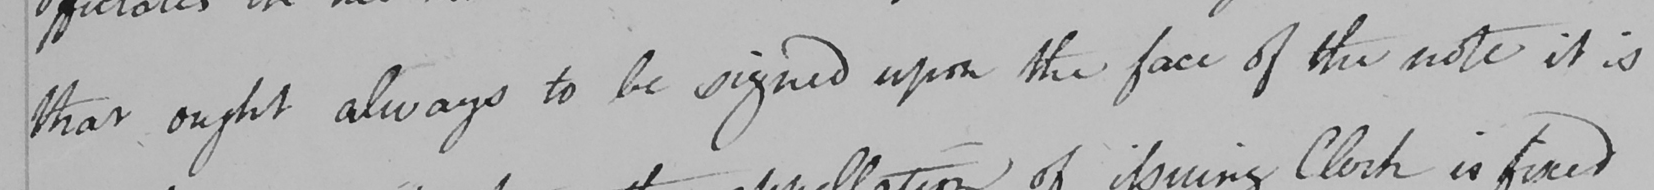What text is written in this handwritten line? that ought always to be signed upon the face of the note it is 